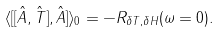Convert formula to latex. <formula><loc_0><loc_0><loc_500><loc_500>\langle [ [ \hat { A } , \hat { T } ] , \hat { A } ] \rangle _ { 0 } = - R _ { \delta T , \delta H } ( \omega = 0 ) .</formula> 